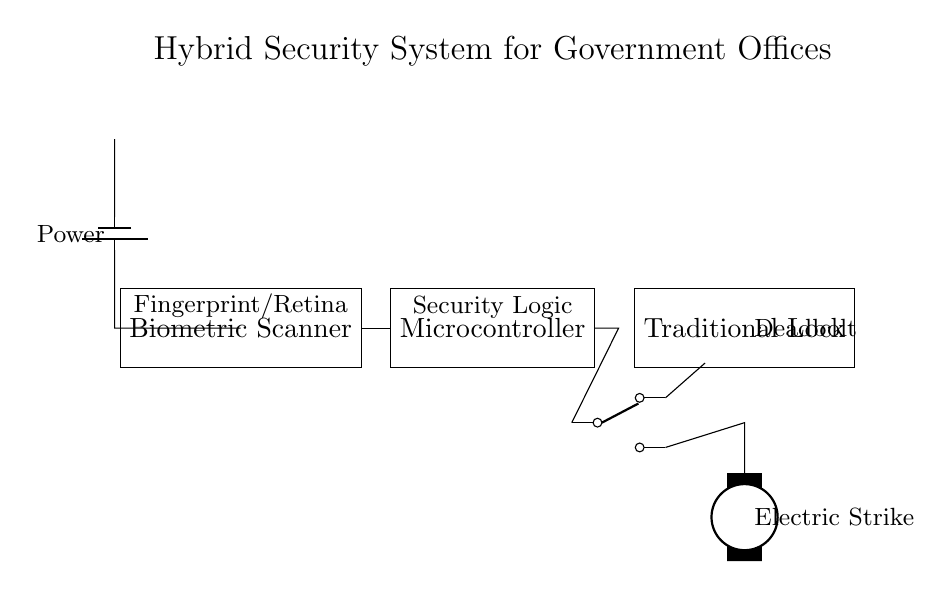What type of scanner is used in this security system? The diagram labels the scanner as a "Biometric Scanner." This identifies the specific type of scanner that employs biometric data like fingerprints or retina scans for access control.
Answer: Biometric Scanner What is the main function of the microcontroller in this system? The microcontroller is labeled "Security Logic," indicating that its primary function is to process the input from the biometric scanner and control the system's security features, such as unlocking the traditional lock.
Answer: Security Logic What component activates the traditional lock? The diagram shows a "Relay" connected to the microcontroller and the lock, implying that the relay activates the lock mechanism. The relay serves as a switch controlled by the microcontroller to engage the lock either through the solenoid or directly.
Answer: Relay What power source is used for this circuit? The circuit features a label indicating "Power" from a battery, showing that the power supply for this hybrid security system is a battery source, providing the necessary voltage for operation.
Answer: Battery How many output paths does the relay have? The relay, represented in the diagram, has two different output paths as indicated by the two outputs shown. This allows it to control two different mechanisms: one to the traditional lock and another to the solenoid mechanism.
Answer: Two Which mechanism is represented as an electric strike? The diagram labels a component as "Electric Strike," clearly indicating that this mechanism is designed for door locking systems that use electrical current to unlatch the door, complementing the traditional lock.
Answer: Electric Strike What type of lock is shown in this security system? The lock is labeled as a "Traditional Lock," which indicates that this system combines biometric technology with a standard mechanical locking mechanism typically used in security systems.
Answer: Traditional Lock 